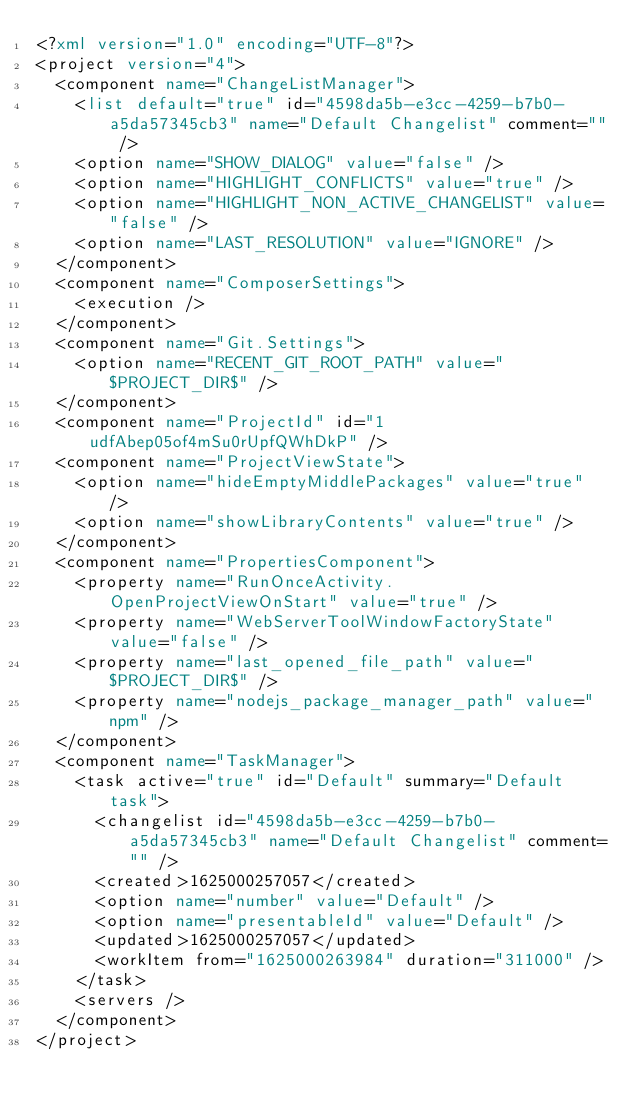Convert code to text. <code><loc_0><loc_0><loc_500><loc_500><_XML_><?xml version="1.0" encoding="UTF-8"?>
<project version="4">
  <component name="ChangeListManager">
    <list default="true" id="4598da5b-e3cc-4259-b7b0-a5da57345cb3" name="Default Changelist" comment="" />
    <option name="SHOW_DIALOG" value="false" />
    <option name="HIGHLIGHT_CONFLICTS" value="true" />
    <option name="HIGHLIGHT_NON_ACTIVE_CHANGELIST" value="false" />
    <option name="LAST_RESOLUTION" value="IGNORE" />
  </component>
  <component name="ComposerSettings">
    <execution />
  </component>
  <component name="Git.Settings">
    <option name="RECENT_GIT_ROOT_PATH" value="$PROJECT_DIR$" />
  </component>
  <component name="ProjectId" id="1udfAbep05of4mSu0rUpfQWhDkP" />
  <component name="ProjectViewState">
    <option name="hideEmptyMiddlePackages" value="true" />
    <option name="showLibraryContents" value="true" />
  </component>
  <component name="PropertiesComponent">
    <property name="RunOnceActivity.OpenProjectViewOnStart" value="true" />
    <property name="WebServerToolWindowFactoryState" value="false" />
    <property name="last_opened_file_path" value="$PROJECT_DIR$" />
    <property name="nodejs_package_manager_path" value="npm" />
  </component>
  <component name="TaskManager">
    <task active="true" id="Default" summary="Default task">
      <changelist id="4598da5b-e3cc-4259-b7b0-a5da57345cb3" name="Default Changelist" comment="" />
      <created>1625000257057</created>
      <option name="number" value="Default" />
      <option name="presentableId" value="Default" />
      <updated>1625000257057</updated>
      <workItem from="1625000263984" duration="311000" />
    </task>
    <servers />
  </component>
</project></code> 